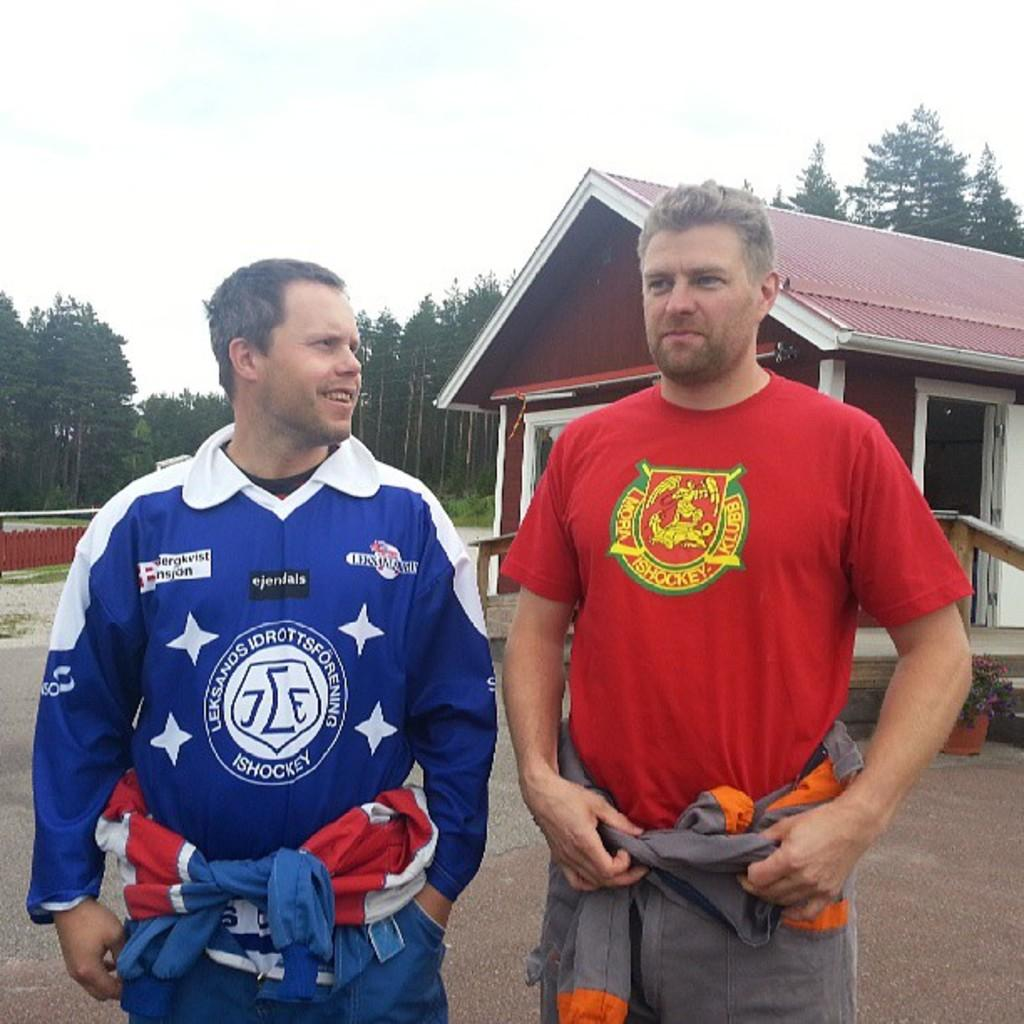<image>
Write a terse but informative summary of the picture. Two men wear different shirts that both have the word ISHOCKEY on them. 